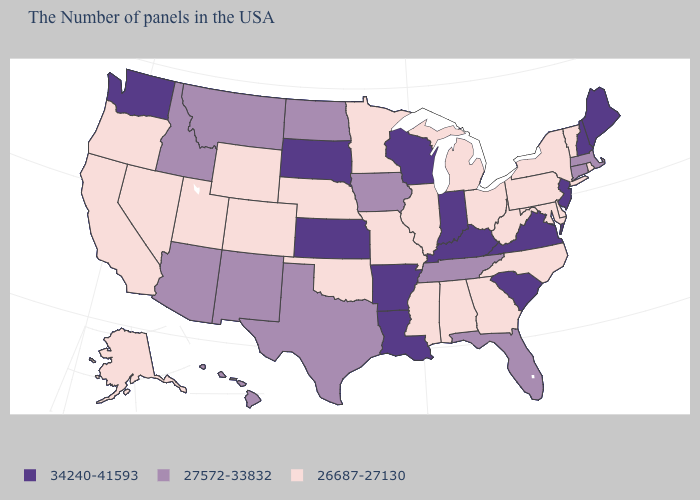Does Michigan have the highest value in the USA?
Concise answer only. No. What is the lowest value in the USA?
Keep it brief. 26687-27130. Which states have the lowest value in the USA?
Answer briefly. Rhode Island, Vermont, New York, Delaware, Maryland, Pennsylvania, North Carolina, West Virginia, Ohio, Georgia, Michigan, Alabama, Illinois, Mississippi, Missouri, Minnesota, Nebraska, Oklahoma, Wyoming, Colorado, Utah, Nevada, California, Oregon, Alaska. What is the value of Connecticut?
Short answer required. 27572-33832. Name the states that have a value in the range 26687-27130?
Concise answer only. Rhode Island, Vermont, New York, Delaware, Maryland, Pennsylvania, North Carolina, West Virginia, Ohio, Georgia, Michigan, Alabama, Illinois, Mississippi, Missouri, Minnesota, Nebraska, Oklahoma, Wyoming, Colorado, Utah, Nevada, California, Oregon, Alaska. What is the value of South Dakota?
Keep it brief. 34240-41593. Does New Hampshire have the highest value in the Northeast?
Keep it brief. Yes. What is the value of New Hampshire?
Answer briefly. 34240-41593. What is the highest value in states that border Pennsylvania?
Quick response, please. 34240-41593. Does Wyoming have the lowest value in the USA?
Keep it brief. Yes. Does the first symbol in the legend represent the smallest category?
Quick response, please. No. Among the states that border Virginia , which have the highest value?
Keep it brief. Kentucky. Name the states that have a value in the range 34240-41593?
Answer briefly. Maine, New Hampshire, New Jersey, Virginia, South Carolina, Kentucky, Indiana, Wisconsin, Louisiana, Arkansas, Kansas, South Dakota, Washington. What is the value of Arizona?
Concise answer only. 27572-33832. Is the legend a continuous bar?
Quick response, please. No. 